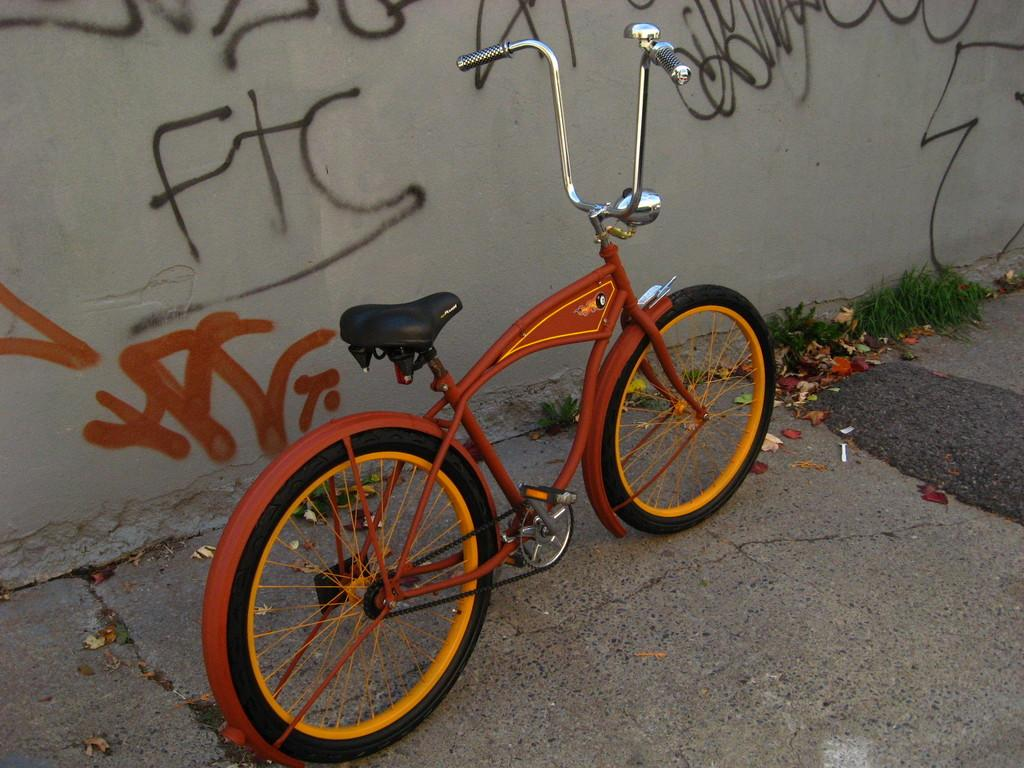What type of vehicle is in the image? There is a red bicycle in the image. Where is the bicycle located? The bicycle is parked on the road. What can be seen on the wall in the image? There is text on the wall in the image. What type of vegetation is on the right side of the image? There is grass on the right side of the image. What else can be found on the right side of the image? There are twigs on the right side of the image. What is the level of wealth depicted in the image? There is no indication of wealth in the image; it features a parked bicycle, a wall with text, grass, and twigs. 